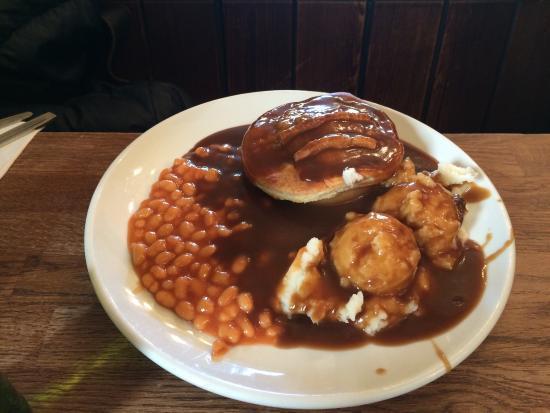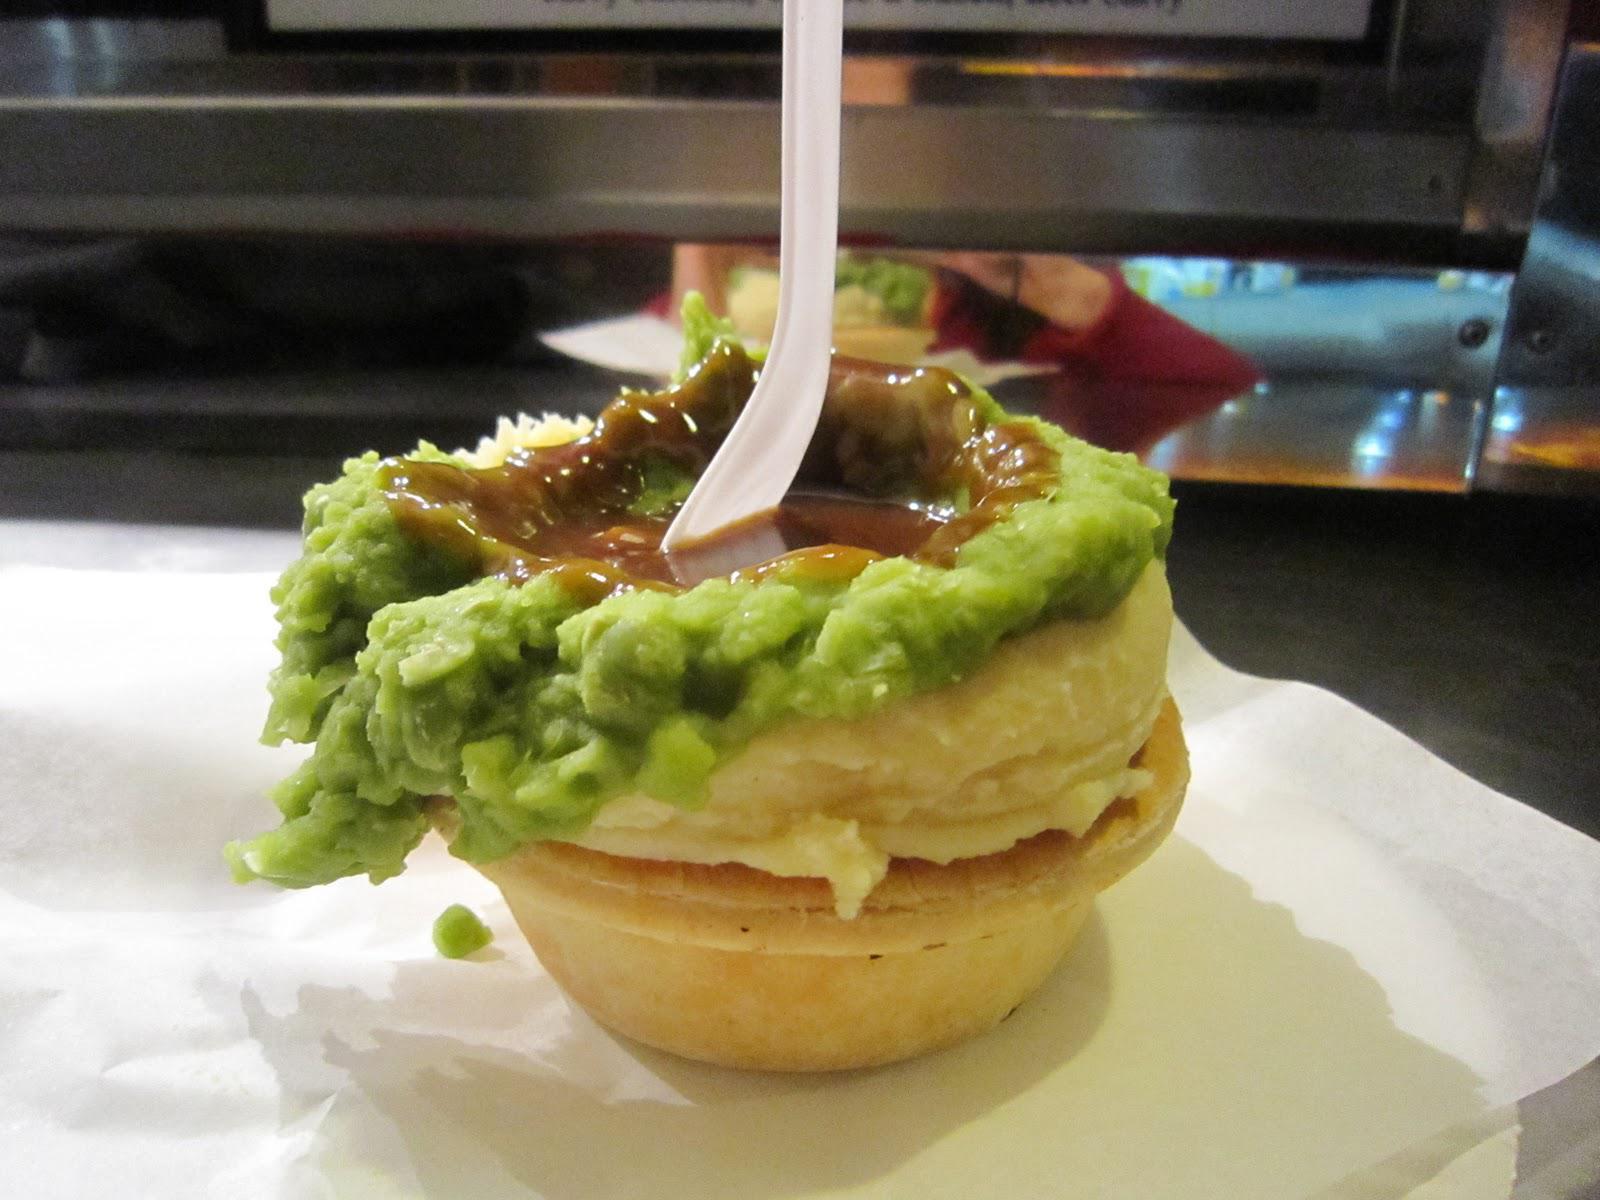The first image is the image on the left, the second image is the image on the right. For the images displayed, is the sentence "In one of the images, a spoon is stuck into the top of the food." factually correct? Answer yes or no. Yes. The first image is the image on the left, the second image is the image on the right. Examine the images to the left and right. Is the description "One image shows a white utensil sticking out of a pool of brown gravy in a pile of mashed green food on mashed white food in a pastry crust." accurate? Answer yes or no. Yes. 